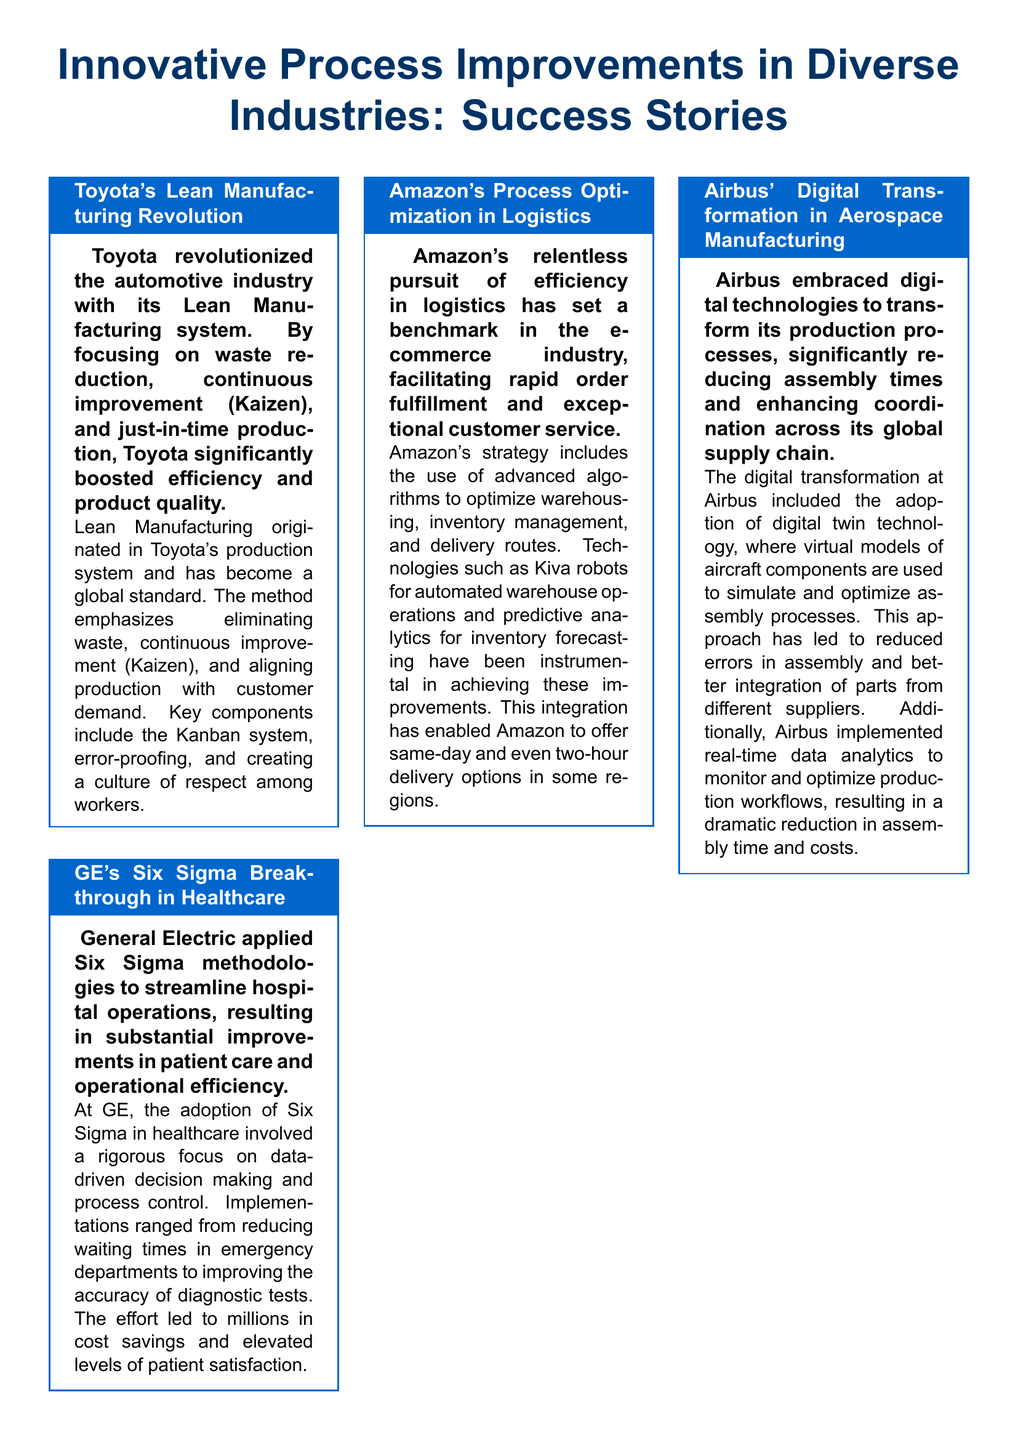What process improvement method did Toyota originate? The document states that Lean Manufacturing originated in Toyota's production system.
Answer: Lean Manufacturing Which industry applied Six Sigma methodologies according to GE? The document mentions that GE applied Six Sigma in healthcare.
Answer: Healthcare What technology did Amazon use for automated warehouse operations? The document lists Kiva robots as the technology used by Amazon.
Answer: Kiva robots What philosophy did Starbucks apply to improve its coffee-making process? The document states that Starbucks applied the Kaizen philosophy.
Answer: Kaizen What was the outcome of Airbus' digital transformation? The document explains that Airbus significantly reduced assembly times.
Answer: Reduced assembly times Which process improvement methodology focuses on waste reduction and customer satisfaction? The document describes methodologies including Lean, Six Sigma, and Business Process Reengineering aimed at enhancing efficiency and effectiveness.
Answer: Lean How did GE's Six Sigma effort benefit patient satisfaction? The document notes that the efforts led to elevated levels of patient satisfaction.
Answer: Elevated levels of patient satisfaction Which section discusses the importance of process improvement? The document specifically titles a section "Why Process Improvement Matters."
Answer: Why Process Improvement Matters What concept did Starbucks use to address inefficiencies in service? The document mentions the 'Lean Store' concept used at Starbucks.
Answer: Lean Store What is emphasized as crucial for maintaining a competitive edge? The document emphasizes that continuous improvement is crucial for maintaining a competitive edge.
Answer: Continuous improvement 